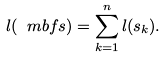<formula> <loc_0><loc_0><loc_500><loc_500>l ( \ m b f { s } ) = \sum _ { k = 1 } ^ { n } l ( s _ { k } ) .</formula> 